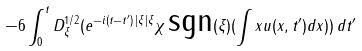<formula> <loc_0><loc_0><loc_500><loc_500>- 6 \int _ { 0 } ^ { t } D _ { \xi } ^ { 1 / 2 } ( e ^ { - i ( t - t ^ { \prime } ) \, | \xi | \xi } \chi \, \text {sgn} ( \xi ) ( \int { x u ( x , t ^ { \prime } ) } d x ) ) \, d t ^ { \prime }</formula> 